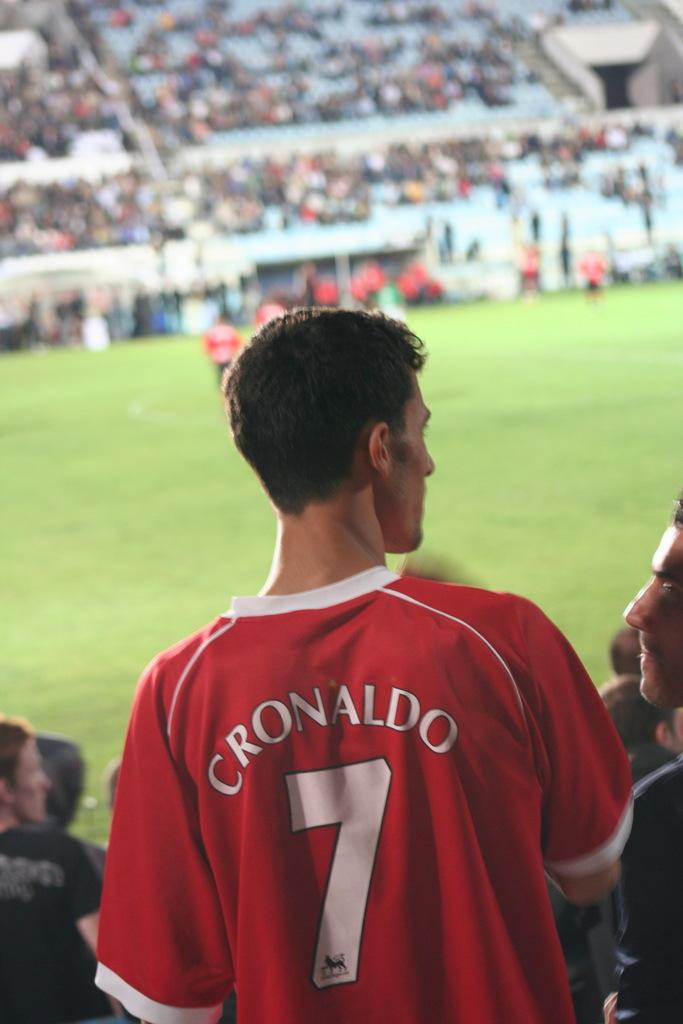Provide a one-sentence caption for the provided image. A young man in a red Cronaldo Jersey stands looking at someone by a soccer field. 